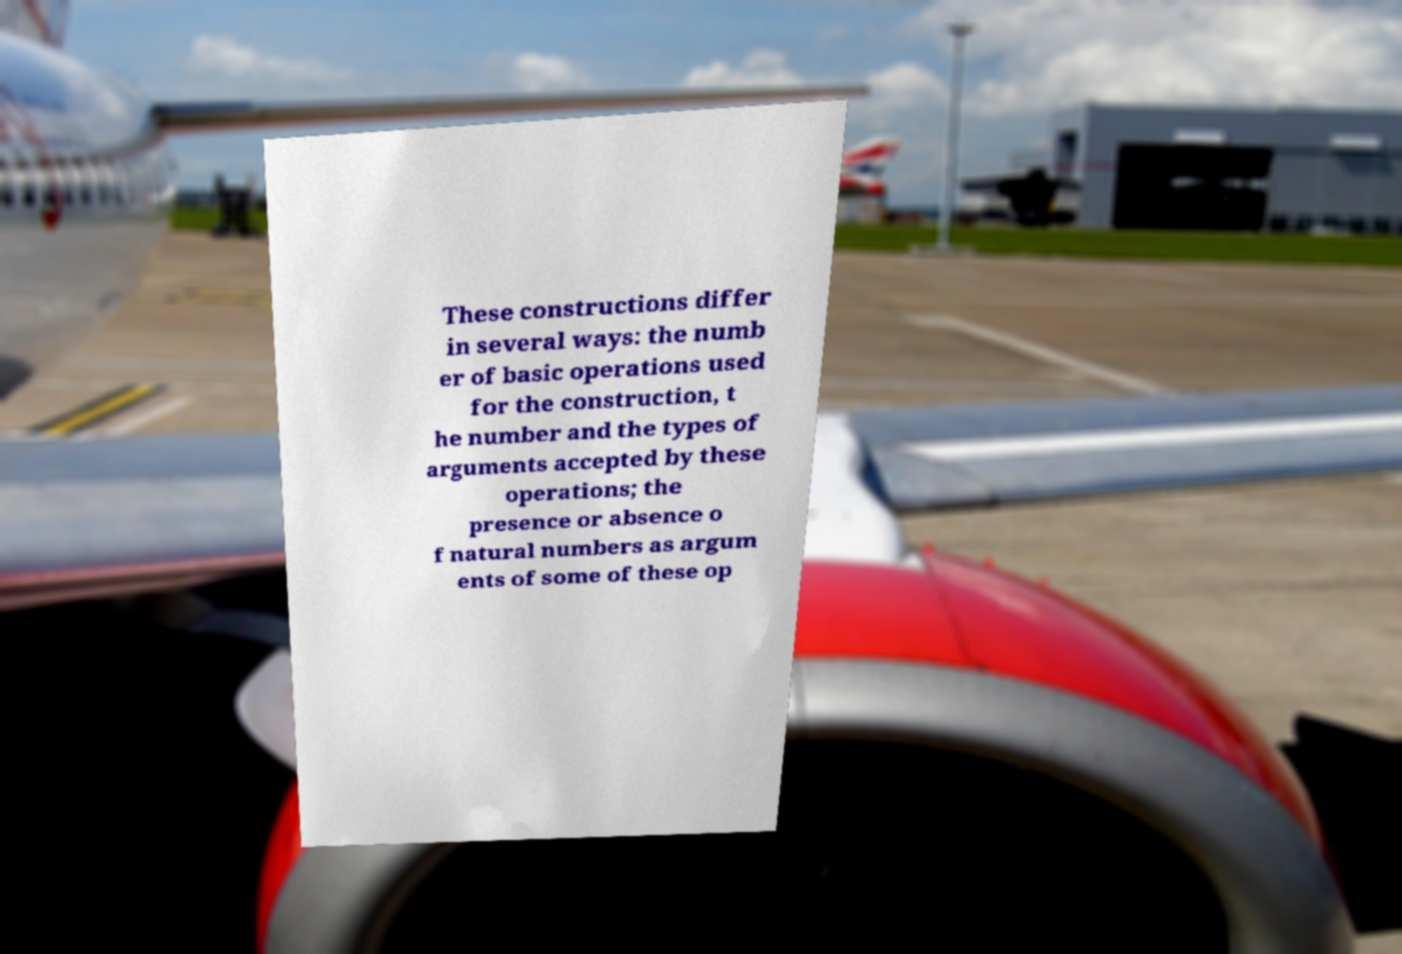I need the written content from this picture converted into text. Can you do that? These constructions differ in several ways: the numb er of basic operations used for the construction, t he number and the types of arguments accepted by these operations; the presence or absence o f natural numbers as argum ents of some of these op 